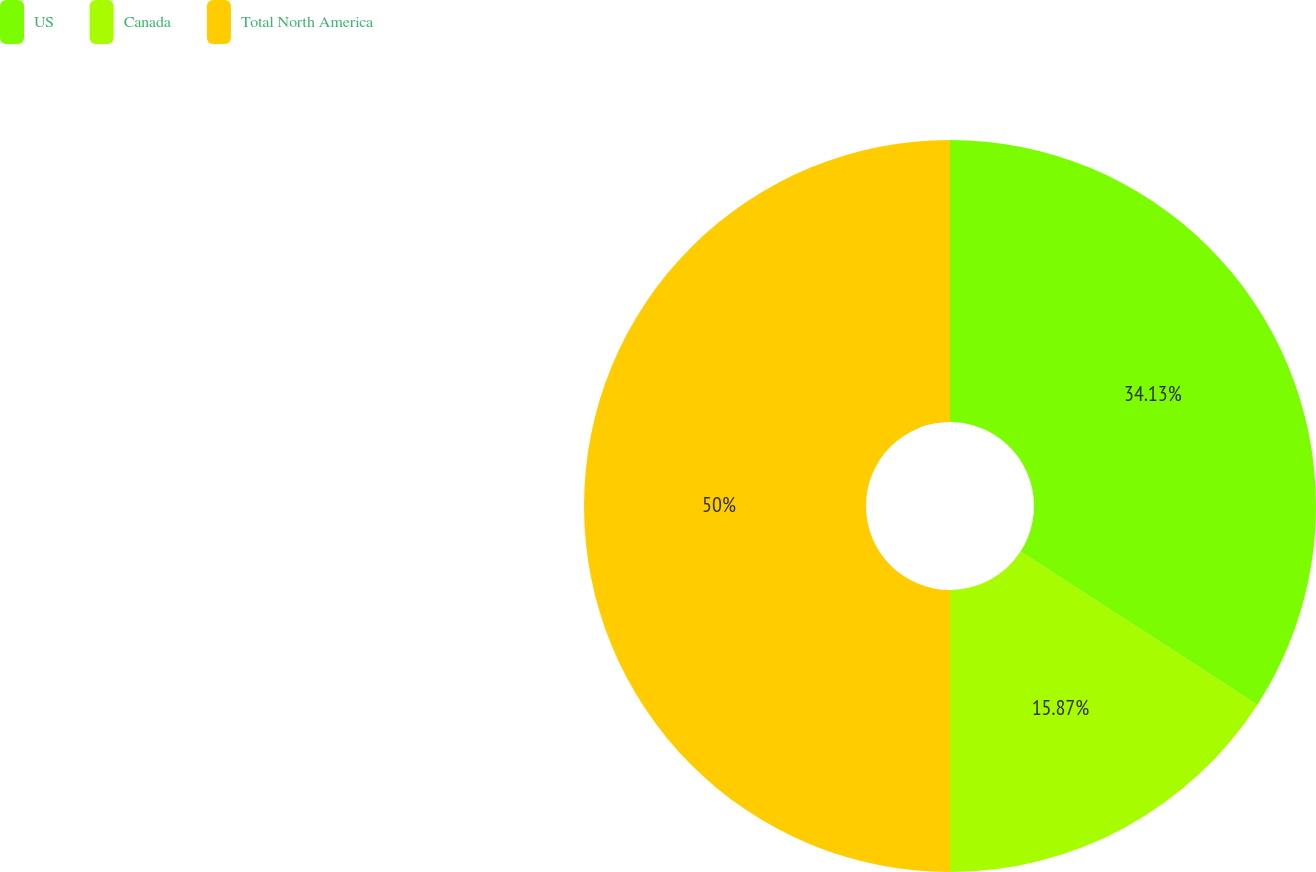<chart> <loc_0><loc_0><loc_500><loc_500><pie_chart><fcel>US<fcel>Canada<fcel>Total North America<nl><fcel>34.13%<fcel>15.87%<fcel>50.0%<nl></chart> 